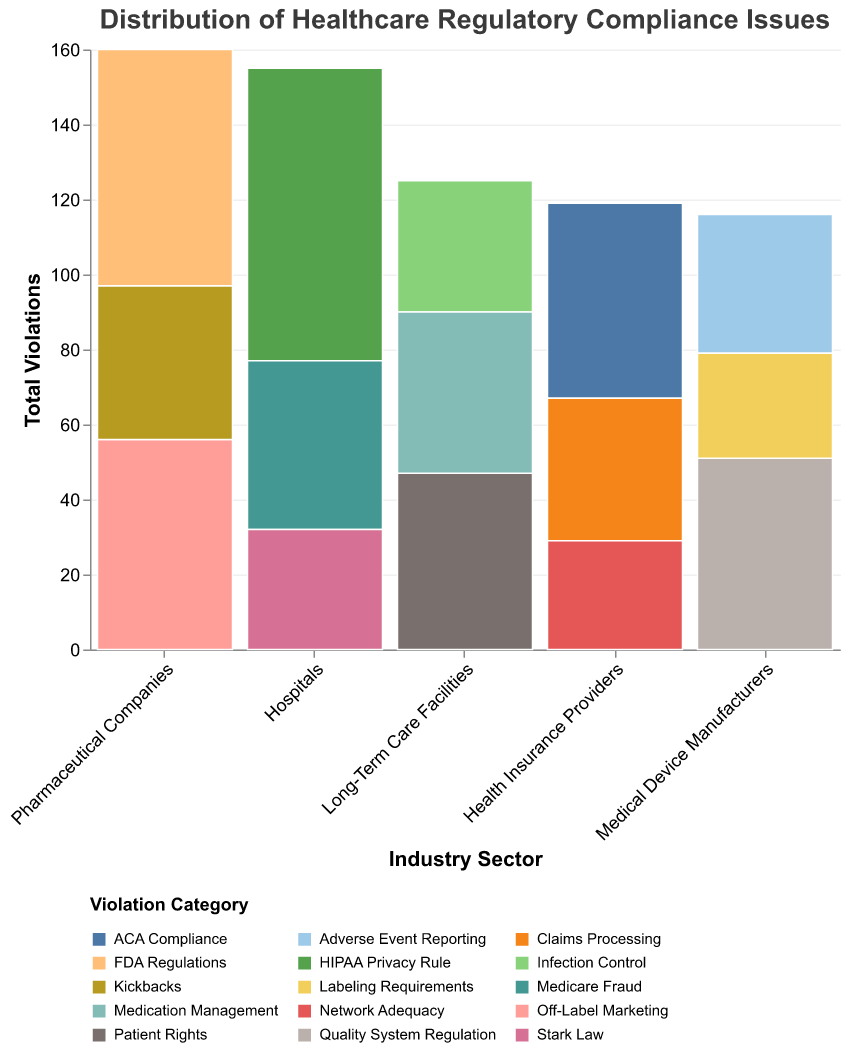What are the three Industry Sectors with the highest total violations? We need to sum the counts of each violation category for each Industry Sector and then determine the top three. The numbers are as follows: Hospitals (155), Pharmaceutical Companies (160), Health Insurance Providers (119), Long-Term Care Facilities (125), and Medical Device Manufacturers (116).
Answer: Pharmaceutical Companies, Hospitals, Long-Term Care Facilities Which Violation Category has the most instances in the dataset? We look at the counts of each violation category across all industry sectors and find the highest count. HIPAA Privacy Rule in Hospitals has 78 instances.
Answer: HIPAA Privacy Rule How do the total violations in Medical Device Manufacturers compare to those in Long-Term Care Facilities? First, we calculate the sum of counts for both sectors: Medical Device Manufacturers (51+37+28=116) and Long-Term Care Facilities (47+35+43=125). Long-Term Care Facilities have more total violations than Medical Device Manufacturers.
Answer: Long-Term Care Facilities have more What is the proportion of Medicare Fraud violations to total violations in Hospitals? Sum all violations in Hospitals (78+45+32=155) and calculate the proportion of Medicare Fraud violations (45/155).
Answer: 29.0% Which Industry Sector has the most diverse types of violations? Count the distinct categories of violations for each sector. Hospitals, Pharmaceutical Companies, Long-Term Care Facilities, and Medical Device Manufacturers each have three categories, while Health Insurance Providers have three as well. None of the sectors have a greater number of distinct violation categories than others.
Answer: All sectors have three types How many total ACA Compliance violations are reported? Sum the counts of ACA Compliance across all industry sectors (only Health Insurance Providers report ACA Compliance violations). There are 52 ACA Compliance violations.
Answer: 52 Which Industry Sector has the fewest total violations? Sum the counts of each sector and find the one with the fewest. Medical Device Manufacturers (116) have the fewest total violations.
Answer: Medical Device Manufacturers What is the difference in the total violations between Pharmaceutical Companies and Health Insurance Providers? Sum the counts for both: Pharmaceutical Companies (56+41+63=160), Health Insurance Providers (52+38+29=119), and calculate the difference (160-119).
Answer: 41 How do the total violations related to Infection Control in Long-Term Care Facilities compare to those related to Adverse Event Reporting in Medical Device Manufacturers? Compare the counts directly: Infection Control in Long-Term Care Facilities is 35, and Adverse Event Reporting in Medical Device Manufacturers is 37.
Answer: Adverse Event Reporting is higher 